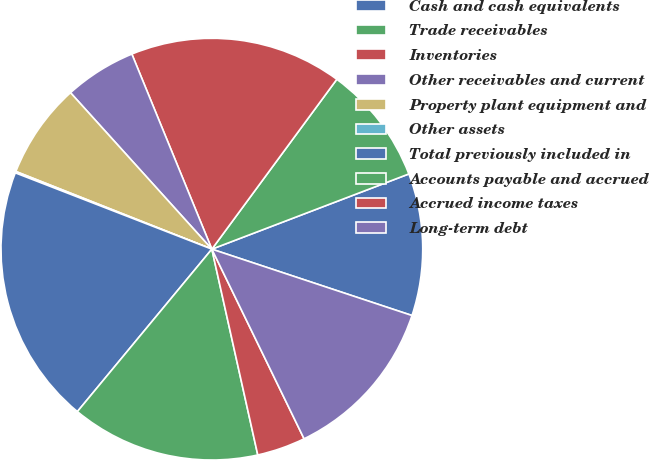Convert chart to OTSL. <chart><loc_0><loc_0><loc_500><loc_500><pie_chart><fcel>Cash and cash equivalents<fcel>Trade receivables<fcel>Inventories<fcel>Other receivables and current<fcel>Property plant equipment and<fcel>Other assets<fcel>Total previously included in<fcel>Accounts payable and accrued<fcel>Accrued income taxes<fcel>Long-term debt<nl><fcel>10.9%<fcel>9.1%<fcel>16.29%<fcel>5.5%<fcel>7.3%<fcel>0.11%<fcel>19.89%<fcel>14.5%<fcel>3.71%<fcel>12.7%<nl></chart> 